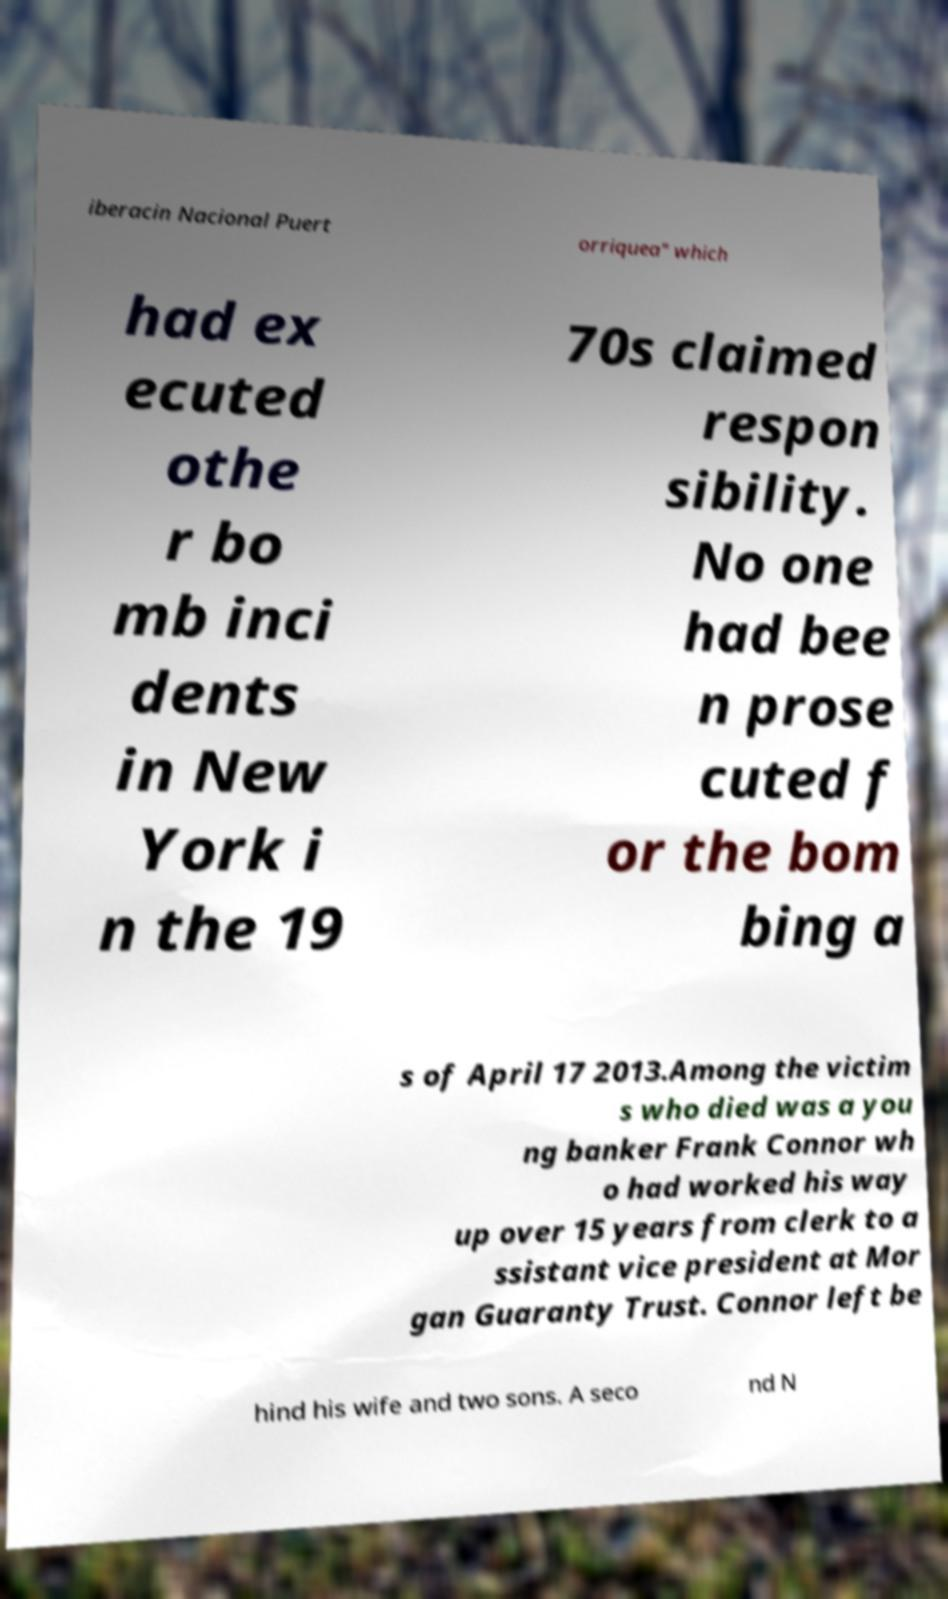Can you accurately transcribe the text from the provided image for me? iberacin Nacional Puert orriquea" which had ex ecuted othe r bo mb inci dents in New York i n the 19 70s claimed respon sibility. No one had bee n prose cuted f or the bom bing a s of April 17 2013.Among the victim s who died was a you ng banker Frank Connor wh o had worked his way up over 15 years from clerk to a ssistant vice president at Mor gan Guaranty Trust. Connor left be hind his wife and two sons. A seco nd N 